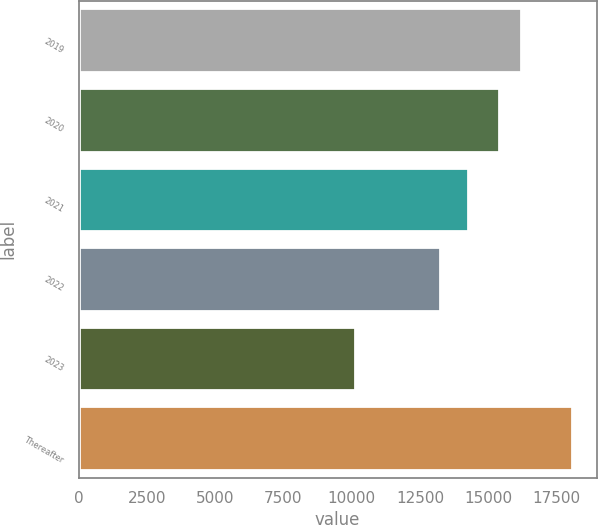Convert chart. <chart><loc_0><loc_0><loc_500><loc_500><bar_chart><fcel>2019<fcel>2020<fcel>2021<fcel>2022<fcel>2023<fcel>Thereafter<nl><fcel>16191.2<fcel>15396<fcel>14272<fcel>13227<fcel>10108<fcel>18060<nl></chart> 